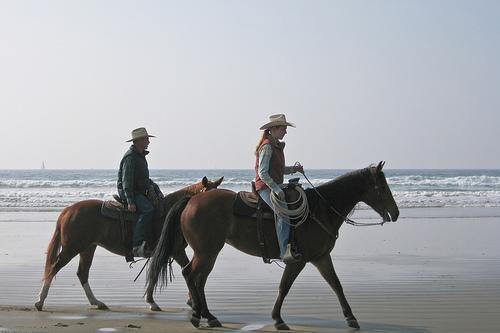How many people are in the picture?
Give a very brief answer. 2. 